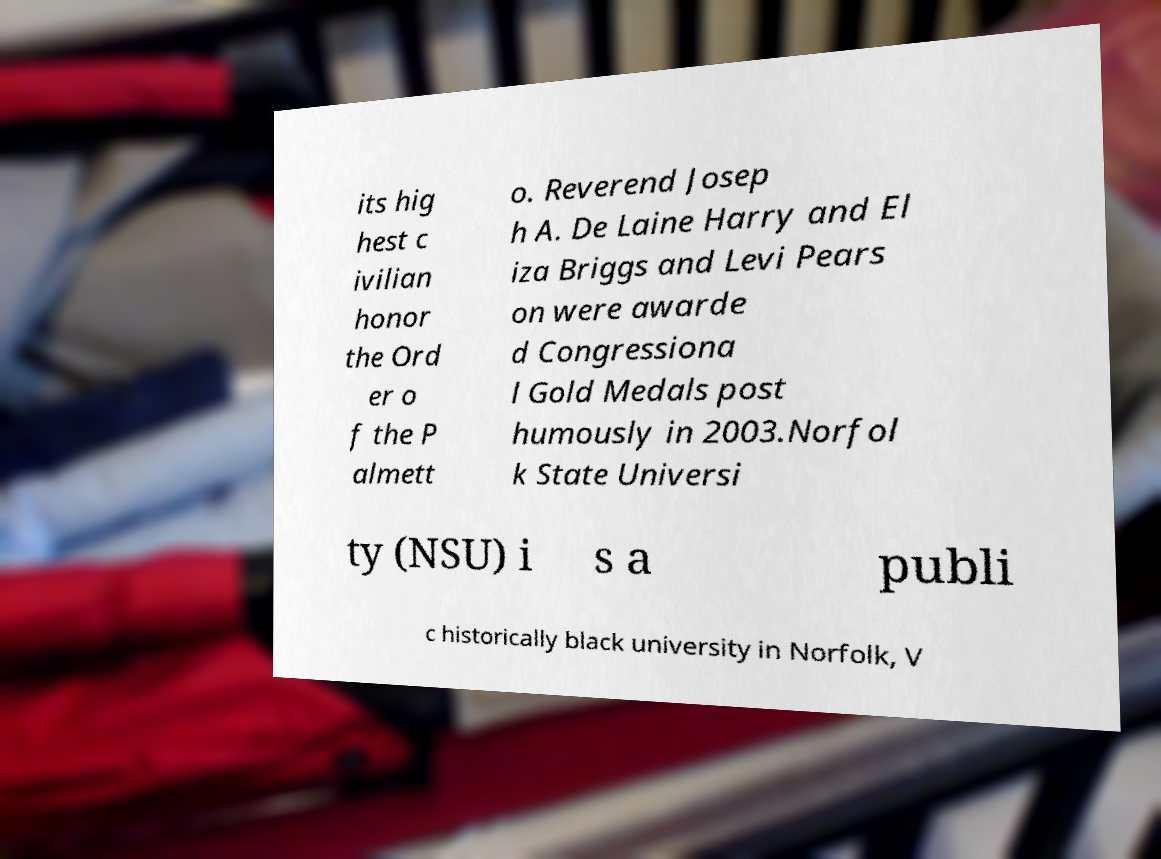Could you assist in decoding the text presented in this image and type it out clearly? its hig hest c ivilian honor the Ord er o f the P almett o. Reverend Josep h A. De Laine Harry and El iza Briggs and Levi Pears on were awarde d Congressiona l Gold Medals post humously in 2003.Norfol k State Universi ty (NSU) i s a publi c historically black university in Norfolk, V 